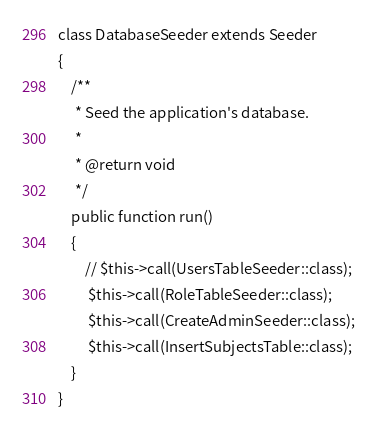<code> <loc_0><loc_0><loc_500><loc_500><_PHP_>
class DatabaseSeeder extends Seeder
{
    /**
     * Seed the application's database.
     *
     * @return void
     */
    public function run()
    {
        // $this->call(UsersTableSeeder::class);
         $this->call(RoleTableSeeder::class);
         $this->call(CreateAdminSeeder::class);
         $this->call(InsertSubjectsTable::class);
    }
}
</code> 